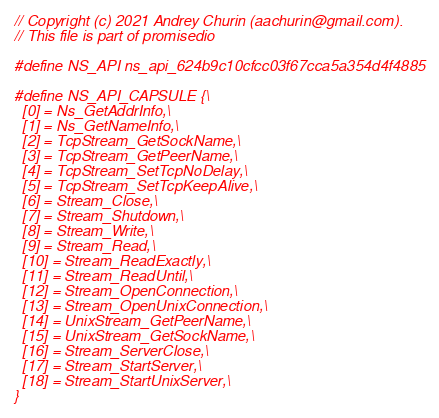<code> <loc_0><loc_0><loc_500><loc_500><_C_>
// Copyright (c) 2021 Andrey Churin (aachurin@gmail.com).
// This file is part of promisedio

#define NS_API ns_api_624b9c10cfcc03f67cca5a354d4f4885

#define NS_API_CAPSULE {\
  [0] = Ns_GetAddrInfo,\
  [1] = Ns_GetNameInfo,\
  [2] = TcpStream_GetSockName,\
  [3] = TcpStream_GetPeerName,\
  [4] = TcpStream_SetTcpNoDelay,\
  [5] = TcpStream_SetTcpKeepAlive,\
  [6] = Stream_Close,\
  [7] = Stream_Shutdown,\
  [8] = Stream_Write,\
  [9] = Stream_Read,\
  [10] = Stream_ReadExactly,\
  [11] = Stream_ReadUntil,\
  [12] = Stream_OpenConnection,\
  [13] = Stream_OpenUnixConnection,\
  [14] = UnixStream_GetPeerName,\
  [15] = UnixStream_GetSockName,\
  [16] = Stream_ServerClose,\
  [17] = Stream_StartServer,\
  [18] = Stream_StartUnixServer,\
}

</code> 